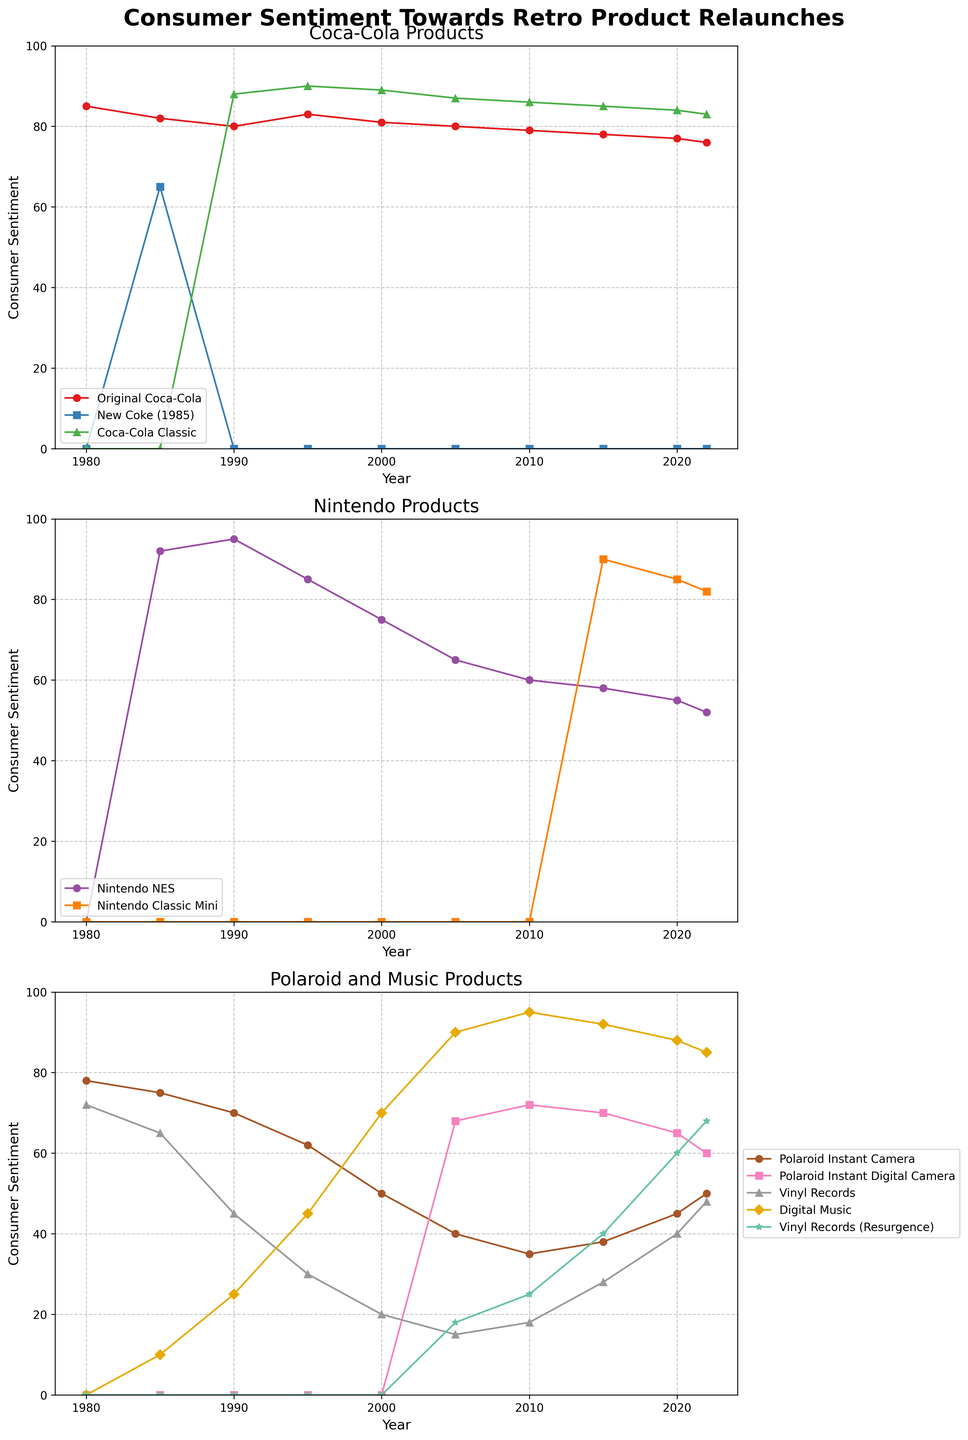Which product had the highest consumer sentiment in 1990? In the 1990 segment, check the values for the different products on all the subplots. Nintendo NES is seen to have a value of 95, which is the highest consumer sentiment for that year.
Answer: Nintendo NES How did the sentiment towards Original Coca-Cola change from 1980 to 2022? Look at the trend line for Original Coca-Cola on the first subplot. The sentiment started at 85 in 1980 and gradually declined to 76 by 2022.
Answer: It declined Between 2015 and 2020, which product saw a larger drop in consumer sentiment: Nintendo Classic Mini or Vinyl Records (Resurgence)? For the Nintendo Classic Mini, the sentiment dropped from 90 in 2015 to 85 in 2020, a decrease of 5 units. For Vinyl Records (Resurgence), the sentiment changed from 40 in 2015 to 60 in 2020, an increase of 20 units. Therefore, Nintendo Classic Mini experienced a drop.
Answer: Nintendo Classic Mini What is the average consumer sentiment for Polaroid Instant Camera from 1980 to 2022? Add up the values for the Polaroid Instant Camera from 1980 to 2022 (78 + 75 + 70 + 62 + 50 + 40 + 35 + 38 + 45 + 50), which equals 543. Divide by the number of years (10) to get the average of 54.3.
Answer: 54.3 Which product had the most consistent (smallest variation) sentiment trend from 1980 to 2022? Observe the lines on the subplots and note the variation for each product. Original Coca-Cola shows a gradual and consistent decline. To quantify, compare the range (max-min) of values over the years for each product. Original Coca-Cola ranges from 85 to 76, a difference of 9, which appears the smallest compared to others.
Answer: Original Coca-Cola In what year did Coca-Cola Classic surpass the sentiment of Original Coca-Cola for the first time? Examine the crossover points in the first subplot. Coca-Cola Classic surpasses Original Coca-Cola in 1990 (88 vs 80).
Answer: 1990 Compare the consumer sentiment trends for Vinyl Records (initial) and Vinyl Records (Resurgence). Which had a sharper increase over time? Look at the slope of the lines for both versions of Vinyl Records across the years on the third subplot. The Vinyl Records (Resurgence) has a more noticeable upward trend from 0 in 1980 to 68 in 2022.
Answer: Vinyl Records (Resurgence) Which year had the highest combined consumer sentiment for Digital Music and Vinyl Records (Resurgence)? Add the sentiment values for Digital Music and Vinyl Records (Resurgence) for each year and compare. The highest combined sentiment is seen in 2022: Digital Music (85) + Vinyl Records (Resurgence) (68) = 153.
Answer: 2022 